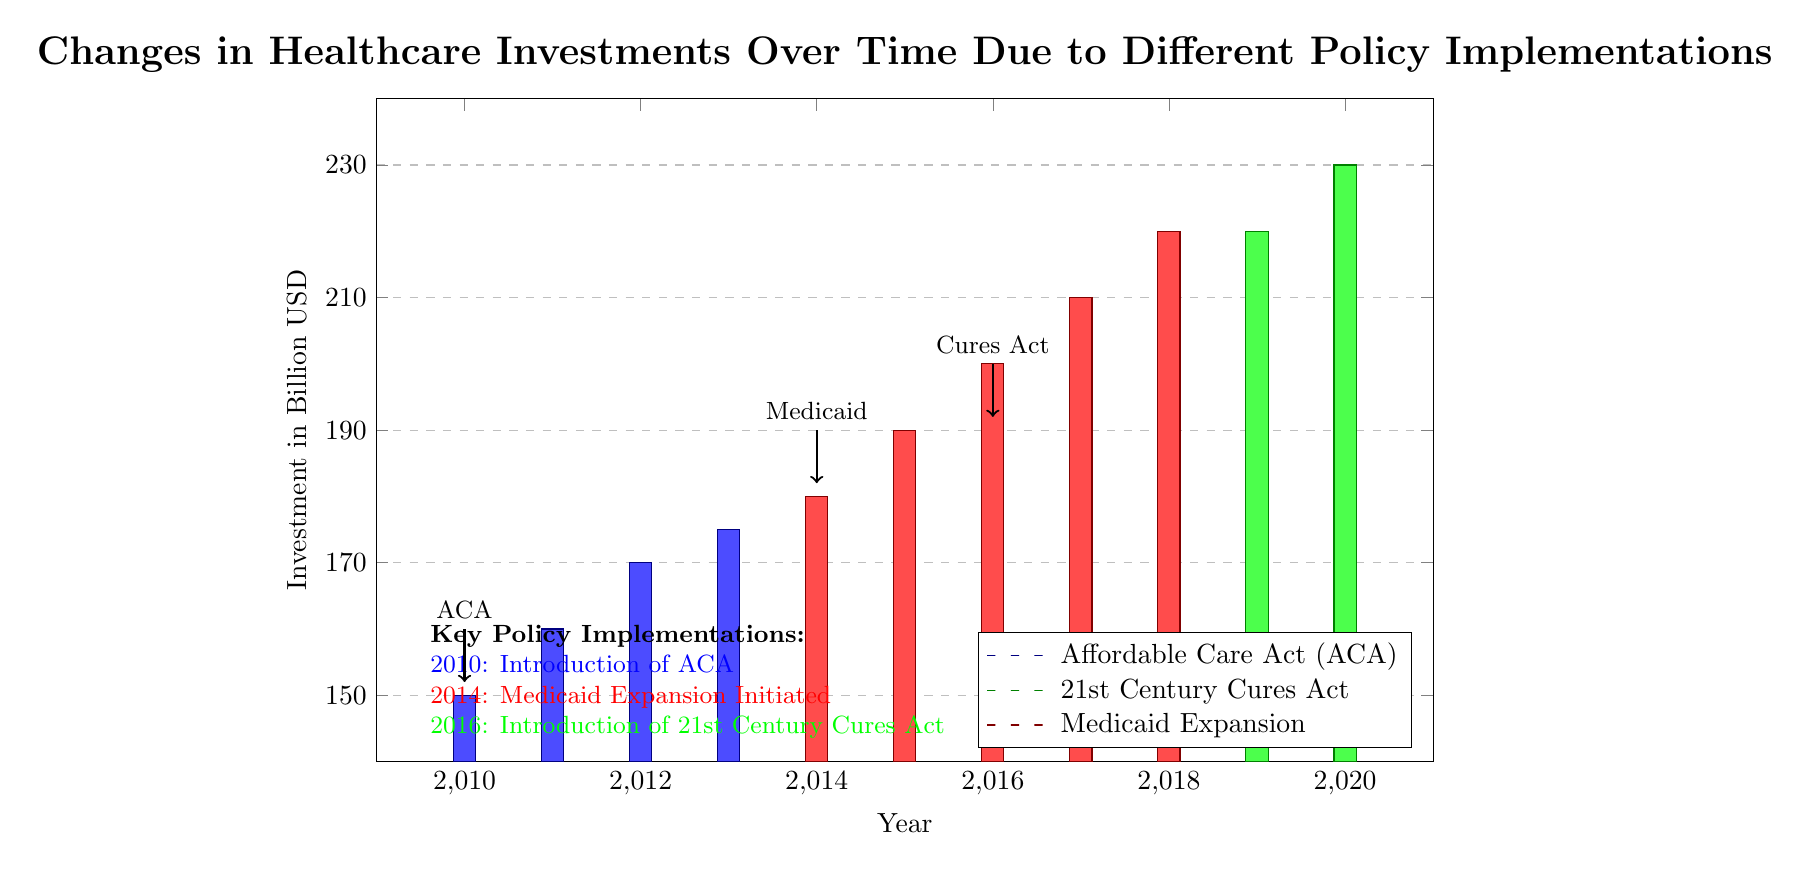What year did the Affordable Care Act (ACA) get implemented? The ACA was introduced in 2010, as stated in the diagram's key policy implementations section and indicated by the blue bar representing that year.
Answer: 2010 What was the investment in healthcare in 2015? In 2015, the diagram shows an investment of 190 billion USD, represented by the red bar for Medicaid Expansion which covers that year.
Answer: 190 billion USD Which year had the highest investment in healthcare? The highest investment is shown for the year 2020, where the green bar representing the 21st Century Cures Act reaches 230 billion USD.
Answer: 230 billion USD What color represents investments made under the Medicaid Expansion policy? The Medicaid Expansion investments are represented by a red color in the diagram, as indicated in the legend.
Answer: Red What is the investment trend from 2010 to 2021? The trend shows a general increase in investment, analyzed by looking at the heights of the bars from 2010 to 2020, reflecting the cumulative impact of the policies over those years.
Answer: Increasing Which two policies were implemented before 2016? The Affordable Care Act and Medicaid Expansion were both implemented before 2016, as noted by their introduction years of 2010 and 2014 respectively in the policy implementation section.
Answer: Affordable Care Act, Medicaid Expansion What investment amount is indicated for the year 2018? The investment for 2018 is represented by a height of 210 billion USD, specifically shown by the green bar associated with the 21st Century Cures Act.
Answer: 210 billion USD How many distinct policy implementations are represented in the diagram? The diagram displays three distinct policy implementations: the Affordable Care Act, Medicaid Expansion, and the 21st Century Cures Act, as outlined in the legend.
Answer: Three In which year did the 21st Century Cures Act get introduced? The 21st Century Cures Act was introduced in the year 2016, as indicated by the green bar starting in that year and corroborated by the key policy implementations section.
Answer: 2016 